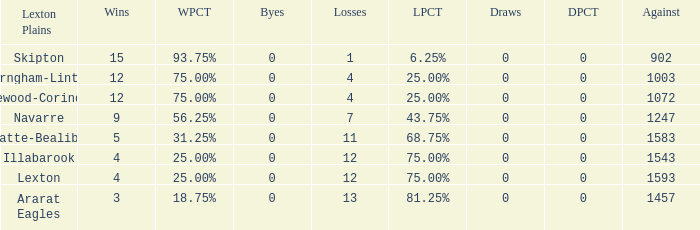What is the most wins with 0 byes? None. 